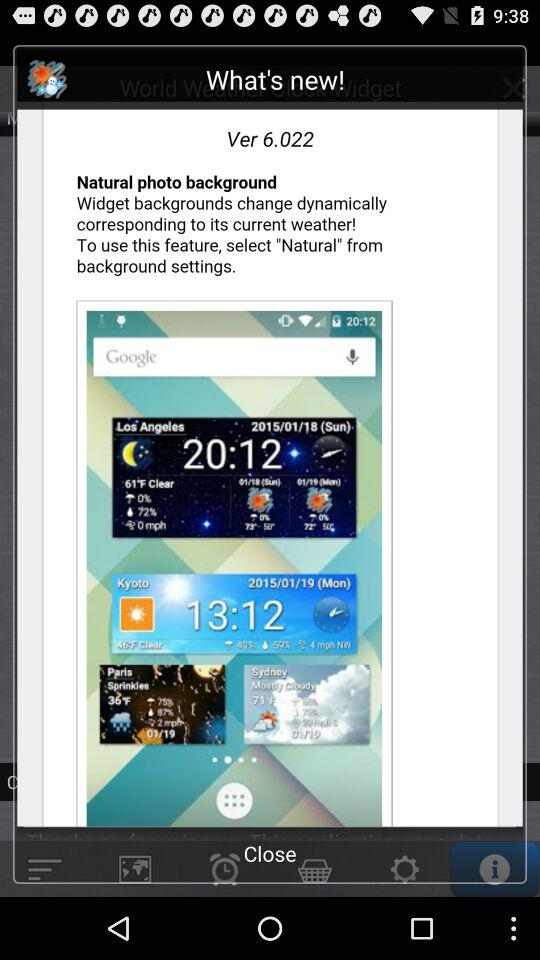What is the version of the application? The version is 6.022. 